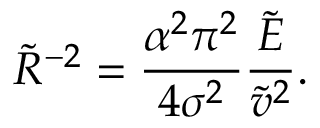Convert formula to latex. <formula><loc_0><loc_0><loc_500><loc_500>\widetilde { R } ^ { - 2 } = \frac { \alpha ^ { 2 } \pi ^ { 2 } } { 4 \sigma ^ { 2 } } \frac { \widetilde { E } } { \widetilde { v } ^ { 2 } } .</formula> 